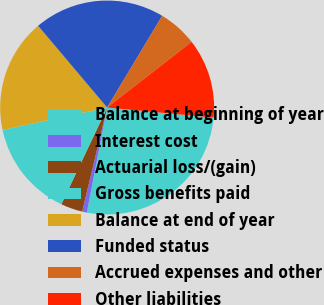<chart> <loc_0><loc_0><loc_500><loc_500><pie_chart><fcel>Balance at beginning of year<fcel>Interest cost<fcel>Actuarial loss/(gain)<fcel>Gross benefits paid<fcel>Balance at end of year<fcel>Funded status<fcel>Accrued expenses and other<fcel>Other liabilities<nl><fcel>26.53%<fcel>0.71%<fcel>3.29%<fcel>14.61%<fcel>17.19%<fcel>19.77%<fcel>5.87%<fcel>12.03%<nl></chart> 